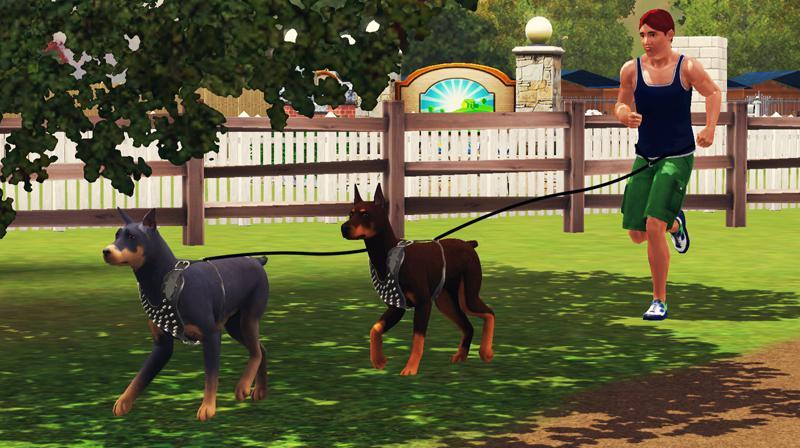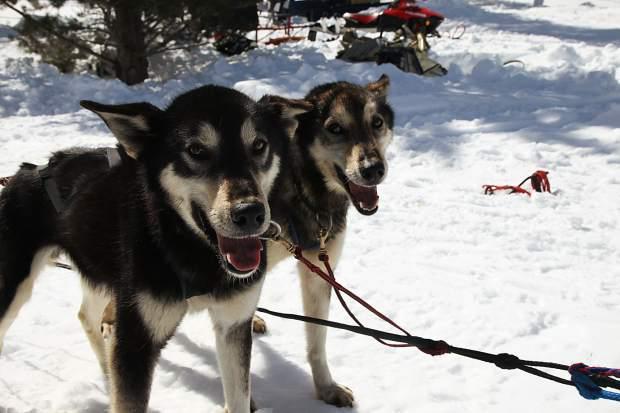The first image is the image on the left, the second image is the image on the right. For the images displayed, is the sentence "Some dogs are wearing booties." factually correct? Answer yes or no. No. The first image is the image on the left, the second image is the image on the right. For the images shown, is this caption "One image shows a sled dog team with a standing sled driver in back moving across the snow, and the other image features at least one creature standing up on two legs." true? Answer yes or no. No. 